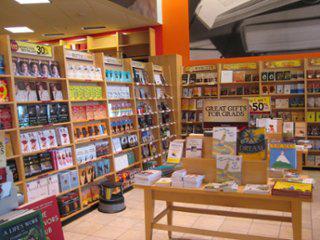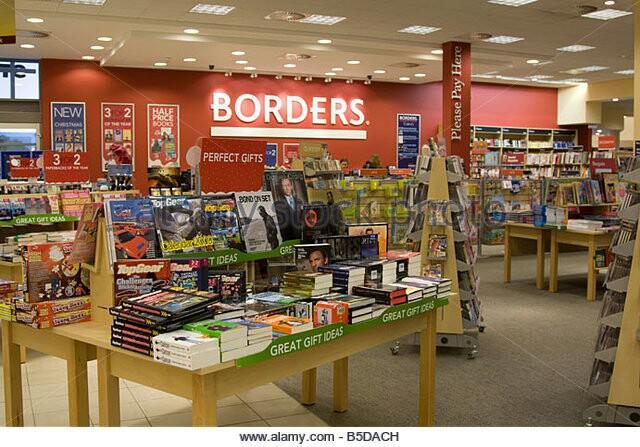The first image is the image on the left, the second image is the image on the right. Examine the images to the left and right. Is the description "There is one person in the bookstore looking at books in one of the images." accurate? Answer yes or no. No. The first image is the image on the left, the second image is the image on the right. Examine the images to the left and right. Is the description "In at least one image there is a single long haired girl looking at book on a brown bookshelf." accurate? Answer yes or no. No. 